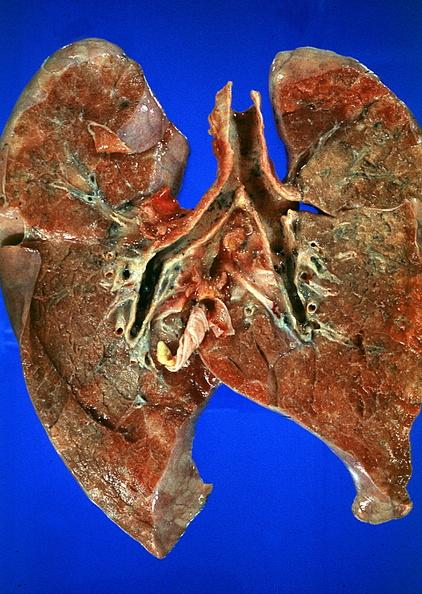what burn smoke inhalation?
Answer the question using a single word or phrase. Thermal 